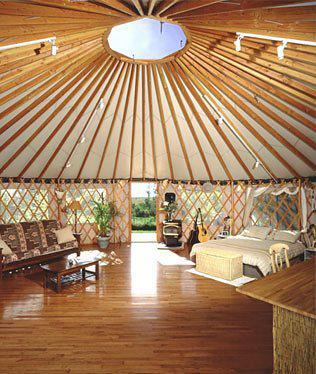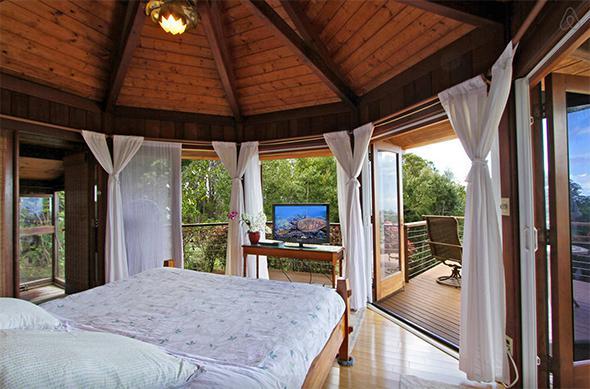The first image is the image on the left, the second image is the image on the right. Examine the images to the left and right. Is the description "One image shows a room with a non-animal patterned run near the center." accurate? Answer yes or no. No. 